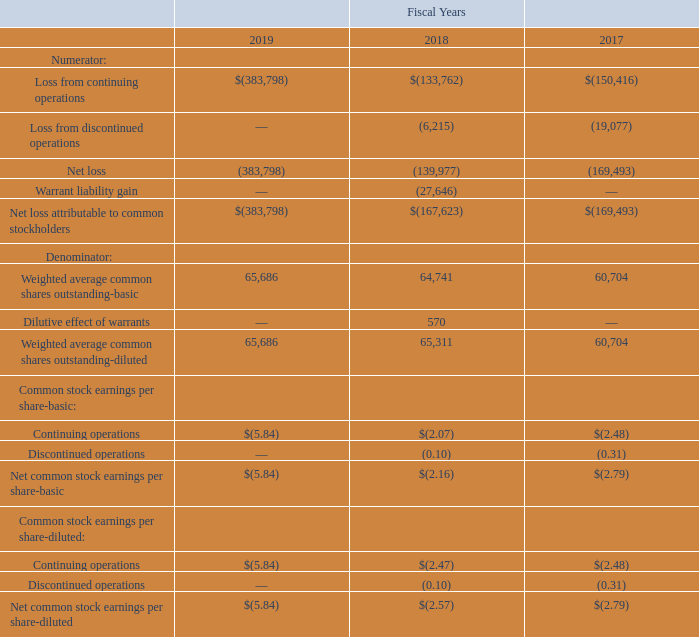24. EARNINGS PER SHARE
The following table set forth the computation for basic and diluted net income (loss) per share of common stock (in thousands, except per share data):
As of September 27, 2019, we had warrants outstanding which were reported as a liability on the consolidated balance sheet. During fiscal years 2019 and 2018, we recorded gains of $0.8 million and $27.6 million, respectively, associated with adjusting the fair value of the warrants, in the Consolidated Statements of Operations primarily as a result of declines in our stock price.
When calculating earnings per share we are required to adjust for the dilutive effect of outstanding common stock equivalents, including adjustment to the numerator for the dilutive effect of contracts that must be settled in common stock. During the fiscal year ended September 27, 2019, we excluded the effects of the warrant gain and the 214,303 of potential shares of common stock issuable upon exercise of warrants as the inclusion would be anti-dilutive.
During the fiscal year ended September 28, 2018, we adjusted the numerator to exclude the warrant gain $27.6 million, and we also adjusted the denominator for the dilutive effect of the incremental warrant shares of 569,667 under the treasury stock method. For the fiscal years 2018, the table above excludes the effects of 375,940 shares of potential shares of common stock issuable upon exercise of stock options, restricted stock and restricted stock units as the inclusion would be anti-dilutive.
The table excludes the effects of 386,552 and 1,877,401 shares for fiscal years 2019 and 2017, respectively, of potential shares of common stock issuable upon exercise of stock options, restricted stock, restricted stock units and warrants as the inclusion would be anti-dilutive.
What were the respective gains in 2019 and 2018? $0.8 million, $27.6 million. What is the adjustment made when calculating earnings per share? The dilutive effect of outstanding common stock equivalents, including adjustment to the numerator for the dilutive effect of contracts that must be settled in common stock. What was the Loss from continuing operations in 2019?
Answer scale should be: thousand. $(383,798). In which year was Loss from discontinued operations 0? Locate and analyze loss from discontinued operations in row 5
answer: 2019. What was the average Net loss for 2017 to 2019?
Answer scale should be: thousand. (383,798 + 139,977 + 169,493) / 3
Answer: 231089.33. What is the change in the Weighted average common shares outstanding-basic from 2018 to 2019?
Answer scale should be: thousand. 65,686 - 64,741
Answer: 945. 